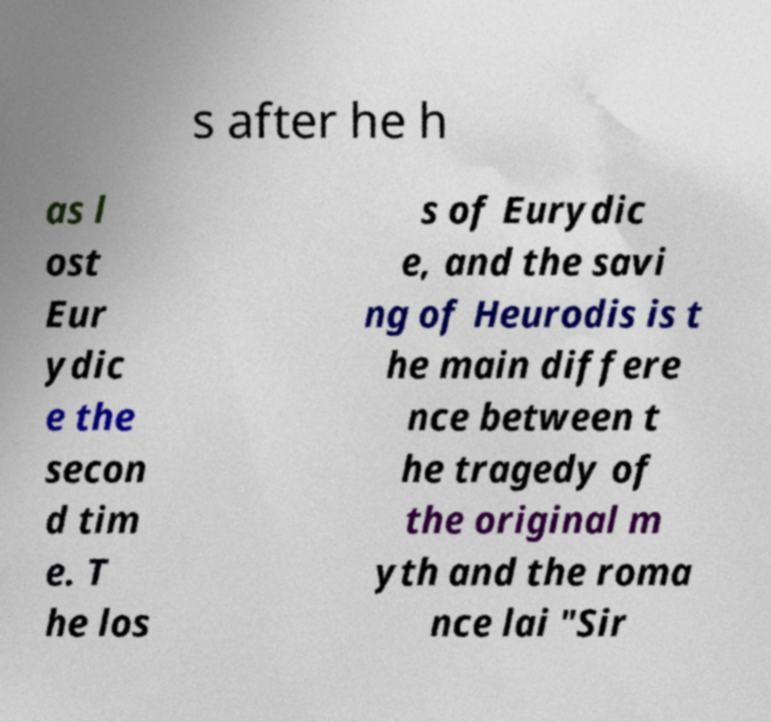Please read and relay the text visible in this image. What does it say? s after he h as l ost Eur ydic e the secon d tim e. T he los s of Eurydic e, and the savi ng of Heurodis is t he main differe nce between t he tragedy of the original m yth and the roma nce lai "Sir 